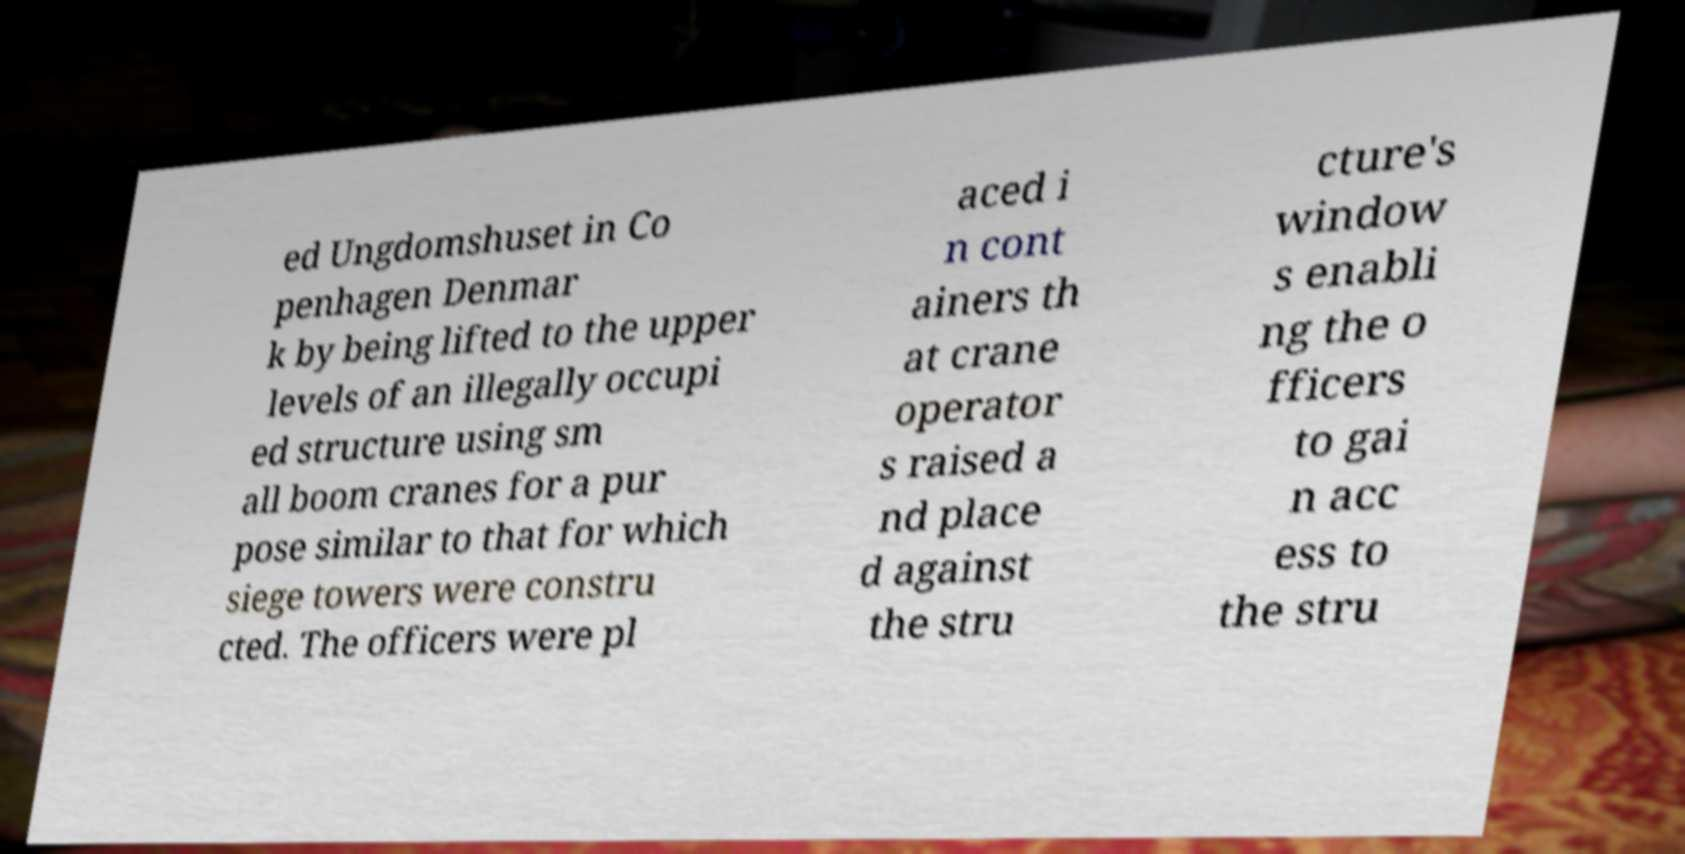Could you extract and type out the text from this image? ed Ungdomshuset in Co penhagen Denmar k by being lifted to the upper levels of an illegally occupi ed structure using sm all boom cranes for a pur pose similar to that for which siege towers were constru cted. The officers were pl aced i n cont ainers th at crane operator s raised a nd place d against the stru cture's window s enabli ng the o fficers to gai n acc ess to the stru 